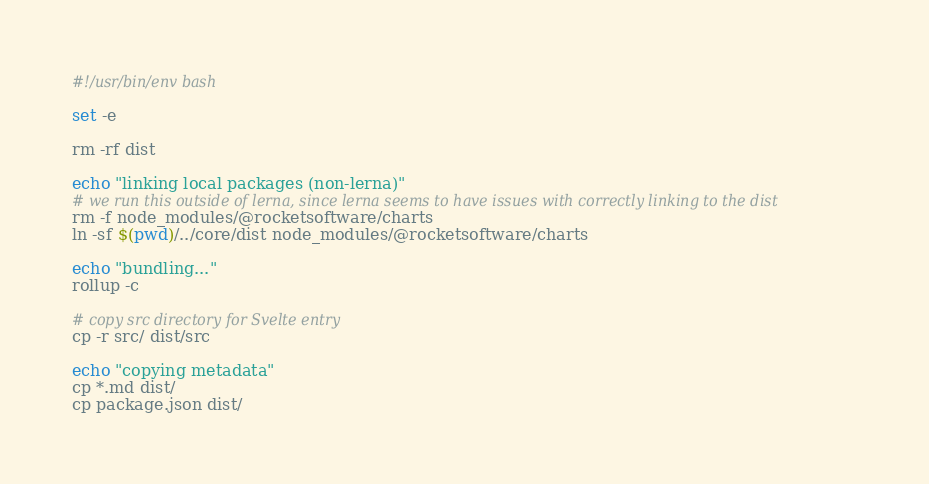Convert code to text. <code><loc_0><loc_0><loc_500><loc_500><_Bash_>#!/usr/bin/env bash

set -e

rm -rf dist

echo "linking local packages (non-lerna)"
# we run this outside of lerna, since lerna seems to have issues with correctly linking to the dist
rm -f node_modules/@rocketsoftware/charts
ln -sf $(pwd)/../core/dist node_modules/@rocketsoftware/charts

echo "bundling..."
rollup -c

# copy src directory for Svelte entry
cp -r src/ dist/src

echo "copying metadata"
cp *.md dist/
cp package.json dist/
</code> 